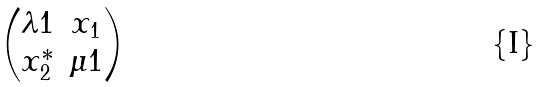<formula> <loc_0><loc_0><loc_500><loc_500>\begin{pmatrix} \lambda 1 & x _ { 1 } \\ x _ { 2 } ^ { * } & \mu 1 \end{pmatrix}</formula> 